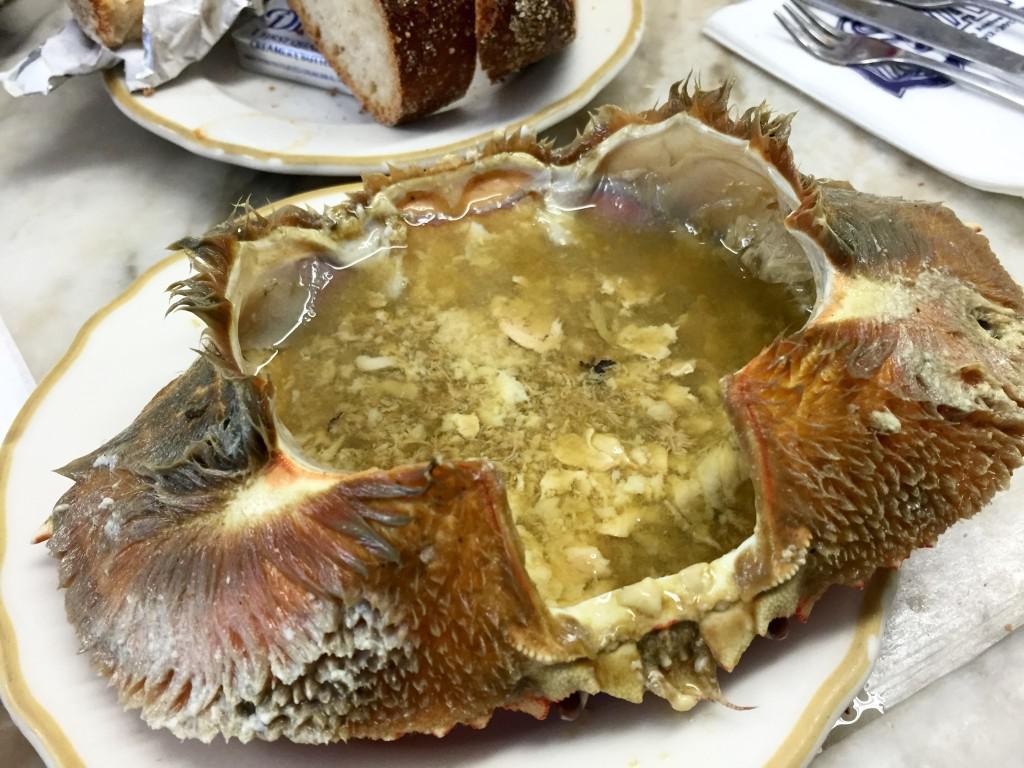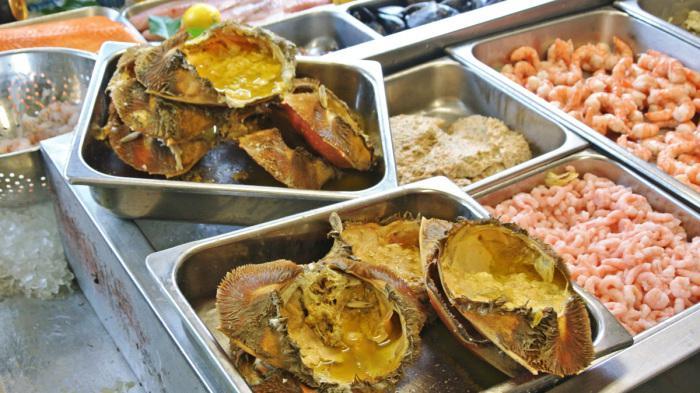The first image is the image on the left, the second image is the image on the right. Evaluate the accuracy of this statement regarding the images: "In the image on the left, there is a dish containing only crab legs.". Is it true? Answer yes or no. No. The first image is the image on the left, the second image is the image on the right. Given the left and right images, does the statement "The left image shows a hollowed-out crab shell on a gold-rimmed plate with yellowish broth inside." hold true? Answer yes or no. Yes. 